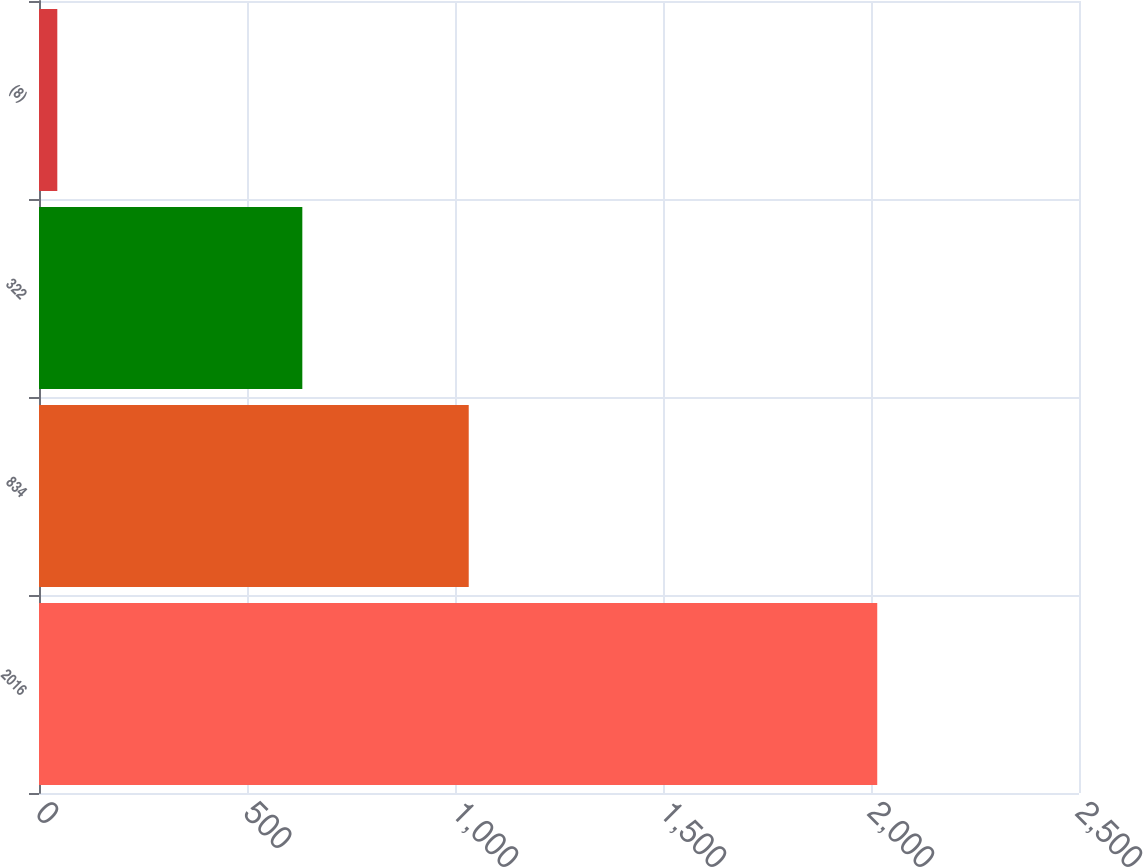Convert chart. <chart><loc_0><loc_0><loc_500><loc_500><bar_chart><fcel>2016<fcel>834<fcel>322<fcel>(8)<nl><fcel>2015<fcel>1033<fcel>633<fcel>44<nl></chart> 